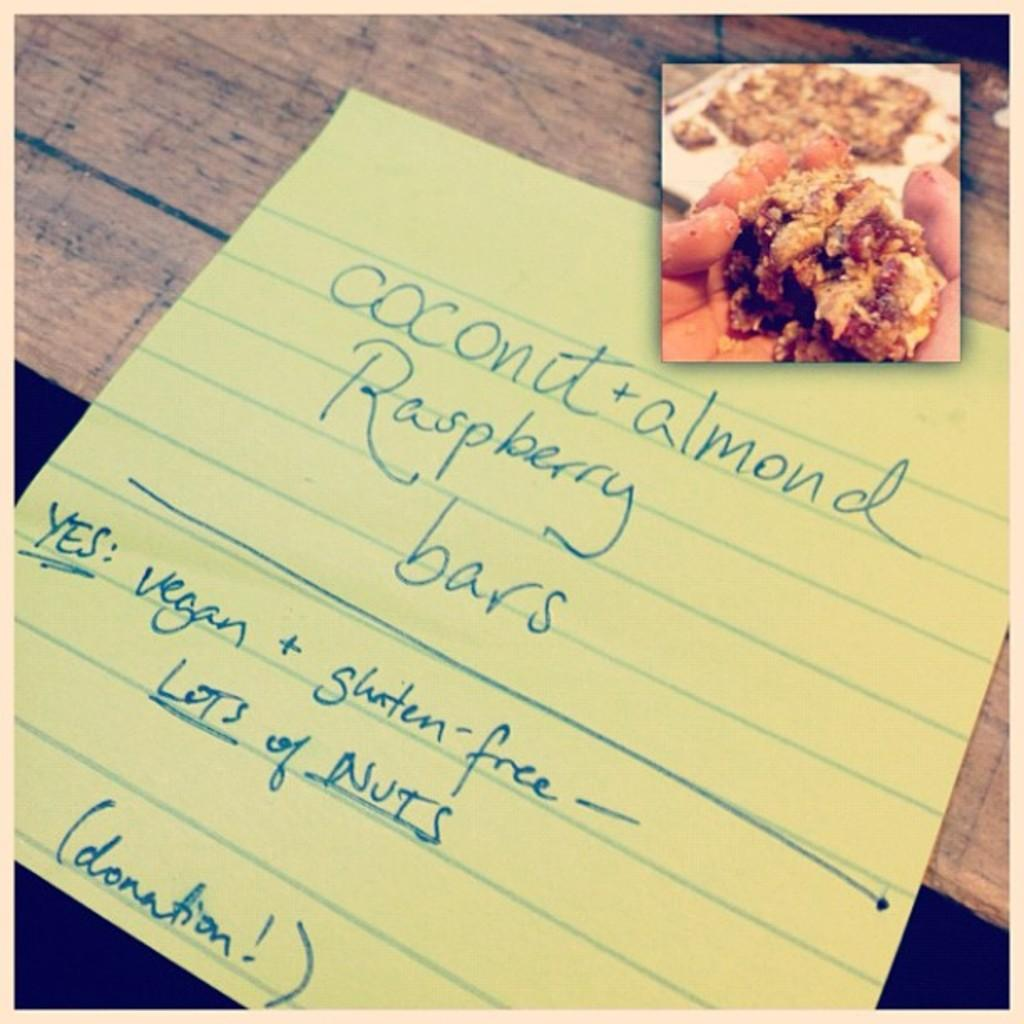<image>
Give a short and clear explanation of the subsequent image. A piece of lined paper with  coconut + almond raspberry bars written on it. 